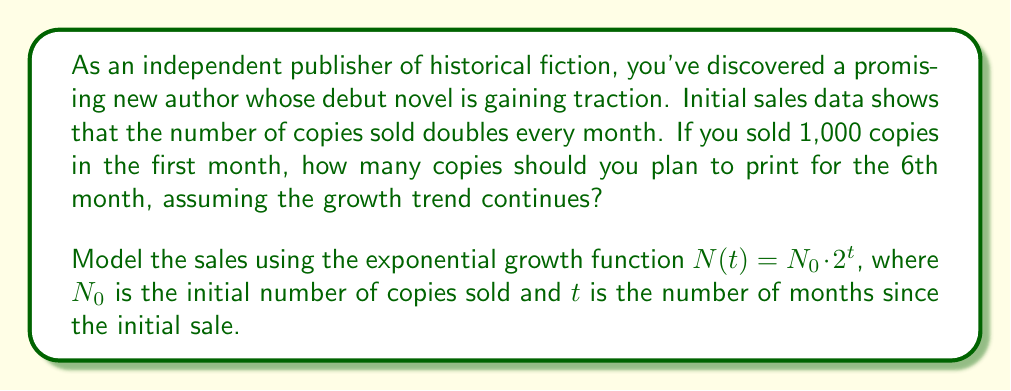Solve this math problem. To solve this problem, we'll use the exponential growth model:

$N(t) = N_0 \cdot 2^t$

Where:
$N(t)$ = Number of copies sold in month $t$
$N_0$ = Initial number of copies sold (1,000 in this case)
$t$ = Number of months since the initial sale

We want to find $N(5)$, as the 6th month is represented by $t=5$ (counting starts from 0).

Let's substitute the values:

$N(5) = 1000 \cdot 2^5$

Now, let's calculate:

$2^5 = 2 \cdot 2 \cdot 2 \cdot 2 \cdot 2 = 32$

Therefore:

$N(5) = 1000 \cdot 32 = 32,000$

This means that by the 6th month, you can expect to sell approximately 32,000 copies based on the exponential growth model.
Answer: 32,000 copies 